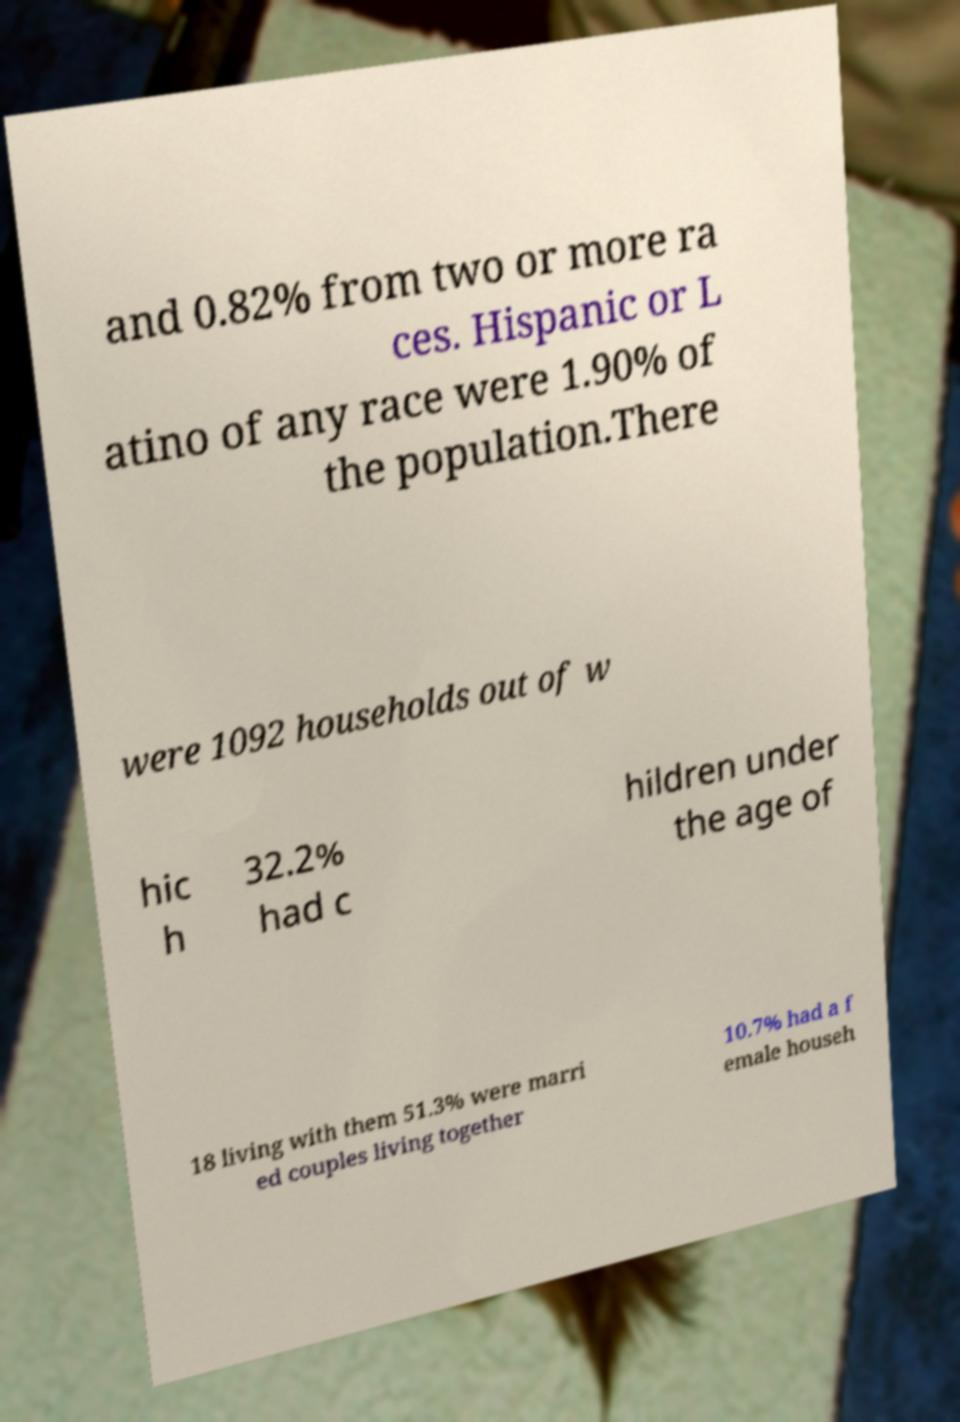Please read and relay the text visible in this image. What does it say? and 0.82% from two or more ra ces. Hispanic or L atino of any race were 1.90% of the population.There were 1092 households out of w hic h 32.2% had c hildren under the age of 18 living with them 51.3% were marri ed couples living together 10.7% had a f emale househ 